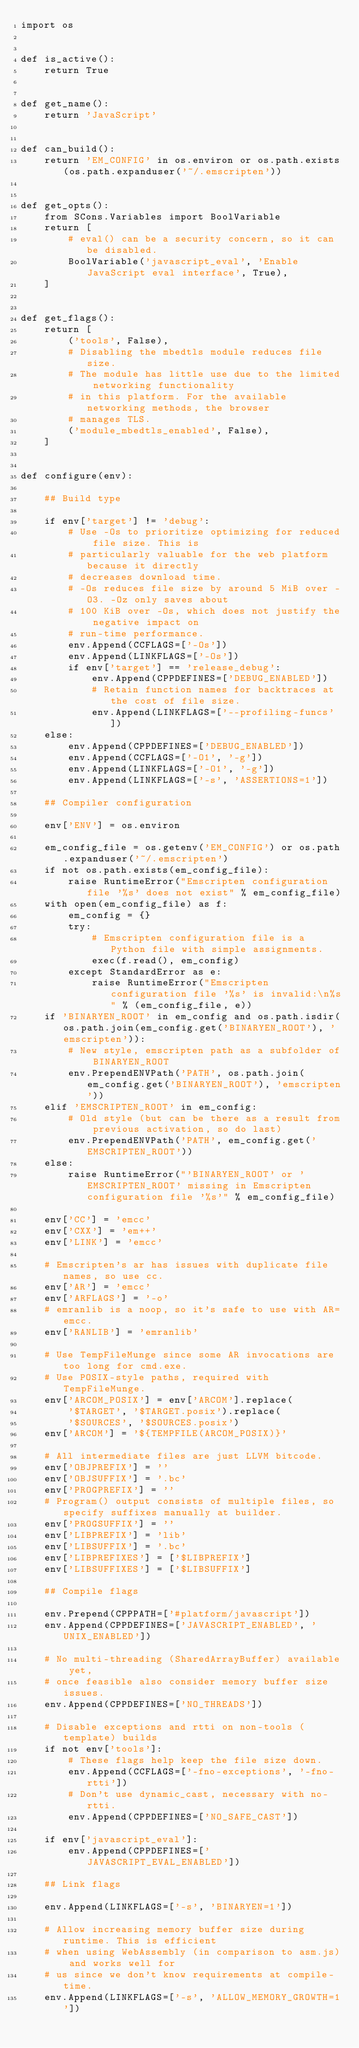<code> <loc_0><loc_0><loc_500><loc_500><_Python_>import os


def is_active():
    return True


def get_name():
    return 'JavaScript'


def can_build():
    return 'EM_CONFIG' in os.environ or os.path.exists(os.path.expanduser('~/.emscripten'))


def get_opts():
    from SCons.Variables import BoolVariable
    return [
        # eval() can be a security concern, so it can be disabled.
        BoolVariable('javascript_eval', 'Enable JavaScript eval interface', True),
    ]


def get_flags():
    return [
        ('tools', False),
        # Disabling the mbedtls module reduces file size.
        # The module has little use due to the limited networking functionality
        # in this platform. For the available networking methods, the browser
        # manages TLS.
        ('module_mbedtls_enabled', False),
    ]


def configure(env):

    ## Build type

    if env['target'] != 'debug':
        # Use -Os to prioritize optimizing for reduced file size. This is
        # particularly valuable for the web platform because it directly
        # decreases download time.
        # -Os reduces file size by around 5 MiB over -O3. -Oz only saves about
        # 100 KiB over -Os, which does not justify the negative impact on
        # run-time performance.
        env.Append(CCFLAGS=['-Os'])
        env.Append(LINKFLAGS=['-Os'])
        if env['target'] == 'release_debug':
            env.Append(CPPDEFINES=['DEBUG_ENABLED'])
            # Retain function names for backtraces at the cost of file size.
            env.Append(LINKFLAGS=['--profiling-funcs'])
    else:
        env.Append(CPPDEFINES=['DEBUG_ENABLED'])
        env.Append(CCFLAGS=['-O1', '-g'])
        env.Append(LINKFLAGS=['-O1', '-g'])
        env.Append(LINKFLAGS=['-s', 'ASSERTIONS=1'])

    ## Compiler configuration

    env['ENV'] = os.environ

    em_config_file = os.getenv('EM_CONFIG') or os.path.expanduser('~/.emscripten')
    if not os.path.exists(em_config_file):
        raise RuntimeError("Emscripten configuration file '%s' does not exist" % em_config_file)
    with open(em_config_file) as f:
        em_config = {}
        try:
            # Emscripten configuration file is a Python file with simple assignments.
            exec(f.read(), em_config)
        except StandardError as e:
            raise RuntimeError("Emscripten configuration file '%s' is invalid:\n%s" % (em_config_file, e))
    if 'BINARYEN_ROOT' in em_config and os.path.isdir(os.path.join(em_config.get('BINARYEN_ROOT'), 'emscripten')):
        # New style, emscripten path as a subfolder of BINARYEN_ROOT
        env.PrependENVPath('PATH', os.path.join(em_config.get('BINARYEN_ROOT'), 'emscripten'))
    elif 'EMSCRIPTEN_ROOT' in em_config:
        # Old style (but can be there as a result from previous activation, so do last)
        env.PrependENVPath('PATH', em_config.get('EMSCRIPTEN_ROOT'))
    else:
        raise RuntimeError("'BINARYEN_ROOT' or 'EMSCRIPTEN_ROOT' missing in Emscripten configuration file '%s'" % em_config_file)

    env['CC'] = 'emcc'
    env['CXX'] = 'em++'
    env['LINK'] = 'emcc'

    # Emscripten's ar has issues with duplicate file names, so use cc.
    env['AR'] = 'emcc'
    env['ARFLAGS'] = '-o'
    # emranlib is a noop, so it's safe to use with AR=emcc.
    env['RANLIB'] = 'emranlib'

    # Use TempFileMunge since some AR invocations are too long for cmd.exe.
    # Use POSIX-style paths, required with TempFileMunge.
    env['ARCOM_POSIX'] = env['ARCOM'].replace(
        '$TARGET', '$TARGET.posix').replace(
        '$SOURCES', '$SOURCES.posix')
    env['ARCOM'] = '${TEMPFILE(ARCOM_POSIX)}'

    # All intermediate files are just LLVM bitcode.
    env['OBJPREFIX'] = ''
    env['OBJSUFFIX'] = '.bc'
    env['PROGPREFIX'] = ''
    # Program() output consists of multiple files, so specify suffixes manually at builder.
    env['PROGSUFFIX'] = ''
    env['LIBPREFIX'] = 'lib'
    env['LIBSUFFIX'] = '.bc'
    env['LIBPREFIXES'] = ['$LIBPREFIX']
    env['LIBSUFFIXES'] = ['$LIBSUFFIX']

    ## Compile flags

    env.Prepend(CPPPATH=['#platform/javascript'])
    env.Append(CPPDEFINES=['JAVASCRIPT_ENABLED', 'UNIX_ENABLED'])

    # No multi-threading (SharedArrayBuffer) available yet,
    # once feasible also consider memory buffer size issues.
    env.Append(CPPDEFINES=['NO_THREADS'])

    # Disable exceptions and rtti on non-tools (template) builds
    if not env['tools']:
        # These flags help keep the file size down.
        env.Append(CCFLAGS=['-fno-exceptions', '-fno-rtti'])
        # Don't use dynamic_cast, necessary with no-rtti.
        env.Append(CPPDEFINES=['NO_SAFE_CAST'])

    if env['javascript_eval']:
        env.Append(CPPDEFINES=['JAVASCRIPT_EVAL_ENABLED'])

    ## Link flags

    env.Append(LINKFLAGS=['-s', 'BINARYEN=1'])

    # Allow increasing memory buffer size during runtime. This is efficient
    # when using WebAssembly (in comparison to asm.js) and works well for
    # us since we don't know requirements at compile-time.
    env.Append(LINKFLAGS=['-s', 'ALLOW_MEMORY_GROWTH=1'])
</code> 